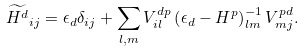<formula> <loc_0><loc_0><loc_500><loc_500>\widetilde { H ^ { d } } _ { i j } = \epsilon _ { d } \delta _ { i j } + \sum _ { l , m } V _ { i l } ^ { d p } \left ( \epsilon _ { d } - H ^ { p } \right ) _ { l m } ^ { - 1 } V _ { m j } ^ { p d } .</formula> 